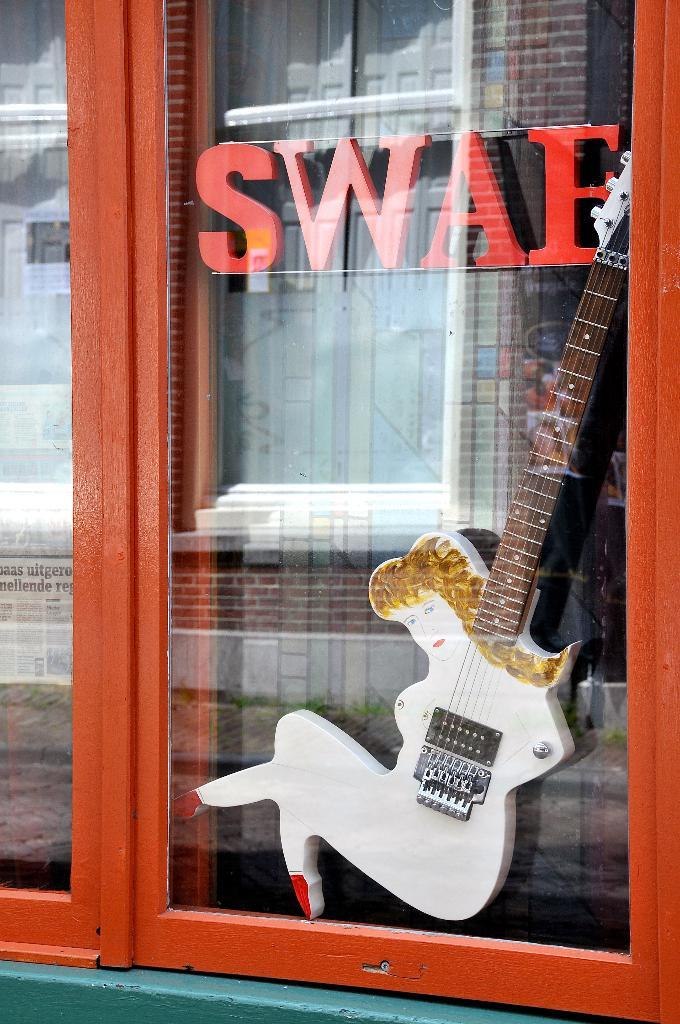What musical instrument can be seen in the image? There is a guitar in the image. What type of architectural feature is present in the image? There is a glass door in the image. What can be read or seen in the image? Text is visible in the image. What type of natural environment is present in the image? There is grass in the image. What type of structure is present in the image? There is a building wall in the image. What time of day was the image likely taken? The image was likely taken during the day, as there is sufficient light to see the details clearly. What type of badge is visible on the guitar in the image? There is no badge present on the guitar in the image. What time does the clock in the image show? There is no clock present in the image. 